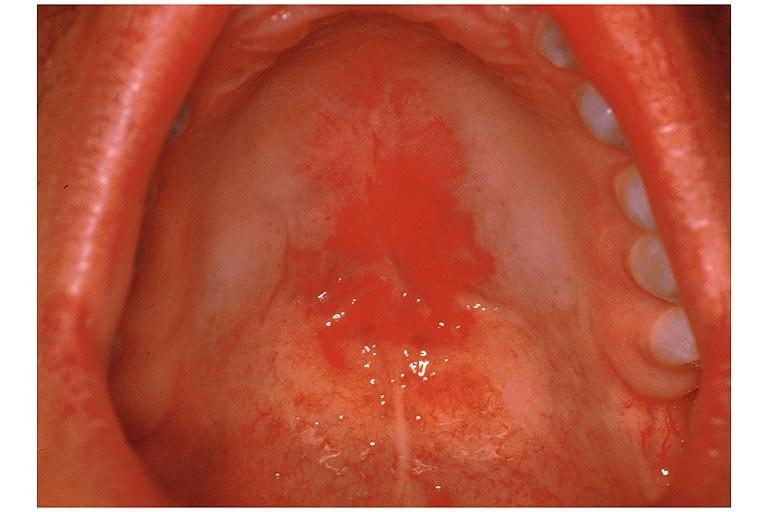s bone, clivus present?
Answer the question using a single word or phrase. No 